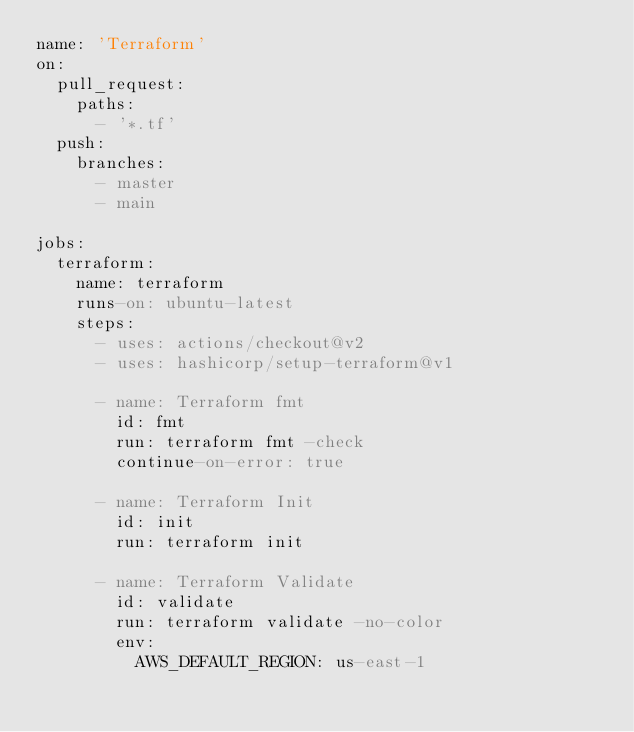<code> <loc_0><loc_0><loc_500><loc_500><_YAML_>name: 'Terraform'
on:
  pull_request:
    paths:
      - '*.tf'
  push:
    branches:
      - master
      - main

jobs:
  terraform:
    name: terraform
    runs-on: ubuntu-latest
    steps:
      - uses: actions/checkout@v2
      - uses: hashicorp/setup-terraform@v1

      - name: Terraform fmt
        id: fmt
        run: terraform fmt -check
        continue-on-error: true

      - name: Terraform Init
        id: init
        run: terraform init

      - name: Terraform Validate
        id: validate
        run: terraform validate -no-color
        env:
          AWS_DEFAULT_REGION: us-east-1
</code> 